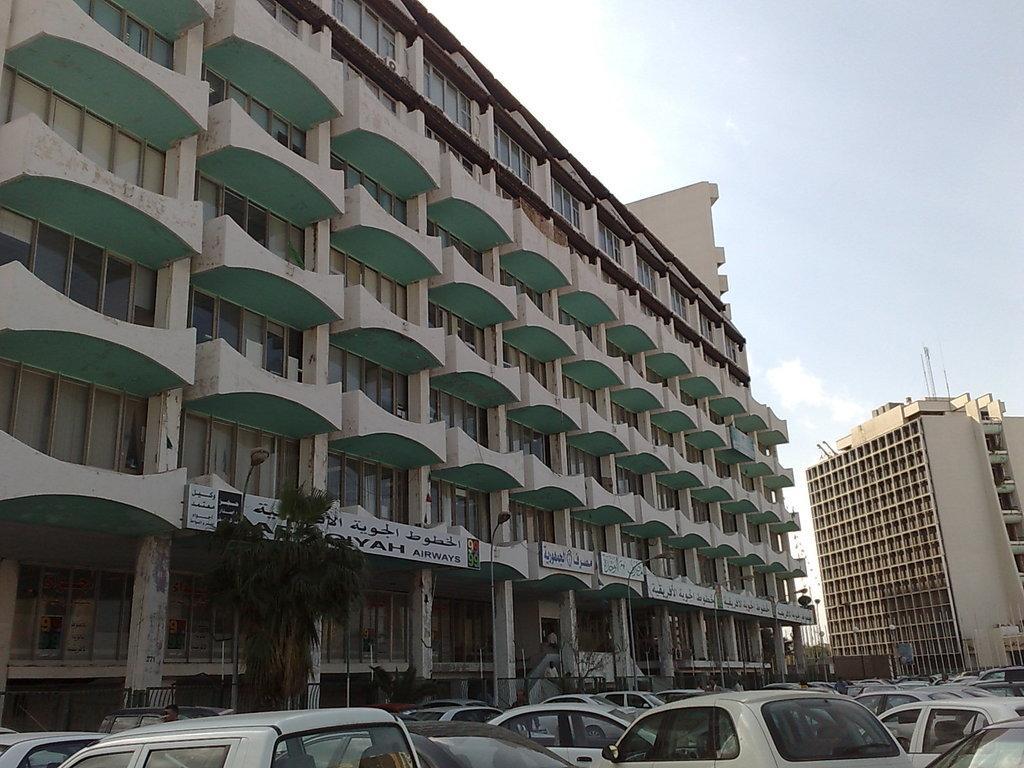Please provide a concise description of this image. In this image in the center there are some buildings, trees, pillars and at the bottom there are some vehicles. And at the top of the image there is sky. 